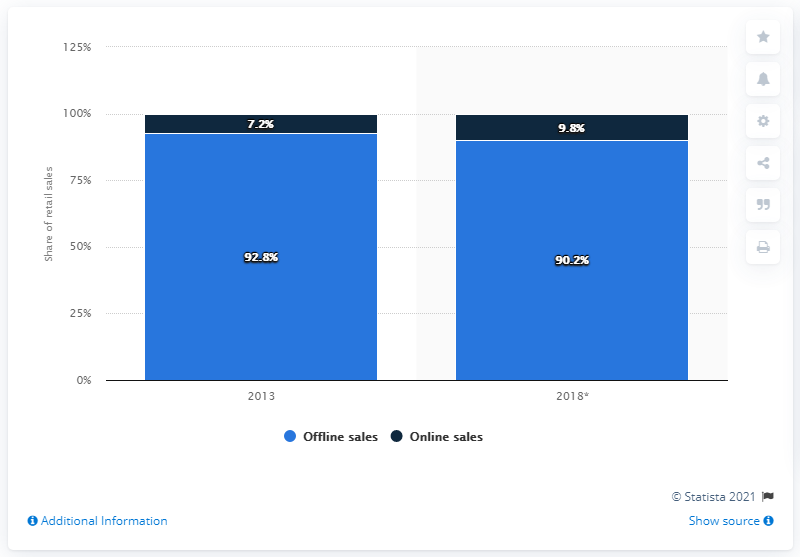Draw attention to some important aspects in this diagram. In 2013, online sales of luggage accounted for approximately 7.2% of total sales. By 2018, it is predicted that the online sales of luggage and leather goods will increase by 9.8%. In 2013, online sales of luggage and leather goods in Germany accounted for 7.2% of total sales in that category. 